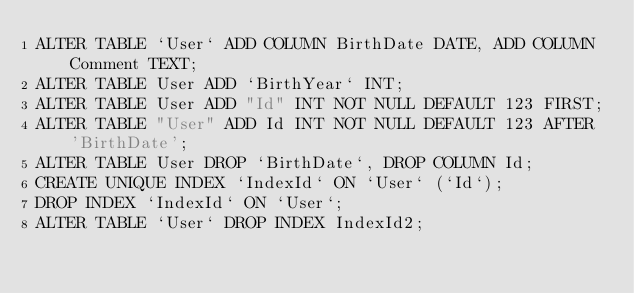<code> <loc_0><loc_0><loc_500><loc_500><_SQL_>ALTER TABLE `User` ADD COLUMN BirthDate DATE, ADD COLUMN Comment TEXT;
ALTER TABLE User ADD `BirthYear` INT;
ALTER TABLE User ADD "Id" INT NOT NULL DEFAULT 123 FIRST;
ALTER TABLE "User" ADD Id INT NOT NULL DEFAULT 123 AFTER 'BirthDate';
ALTER TABLE User DROP `BirthDate`, DROP COLUMN Id;
CREATE UNIQUE INDEX `IndexId` ON `User` (`Id`);
DROP INDEX `IndexId` ON `User`;
ALTER TABLE `User` DROP INDEX IndexId2;
</code> 